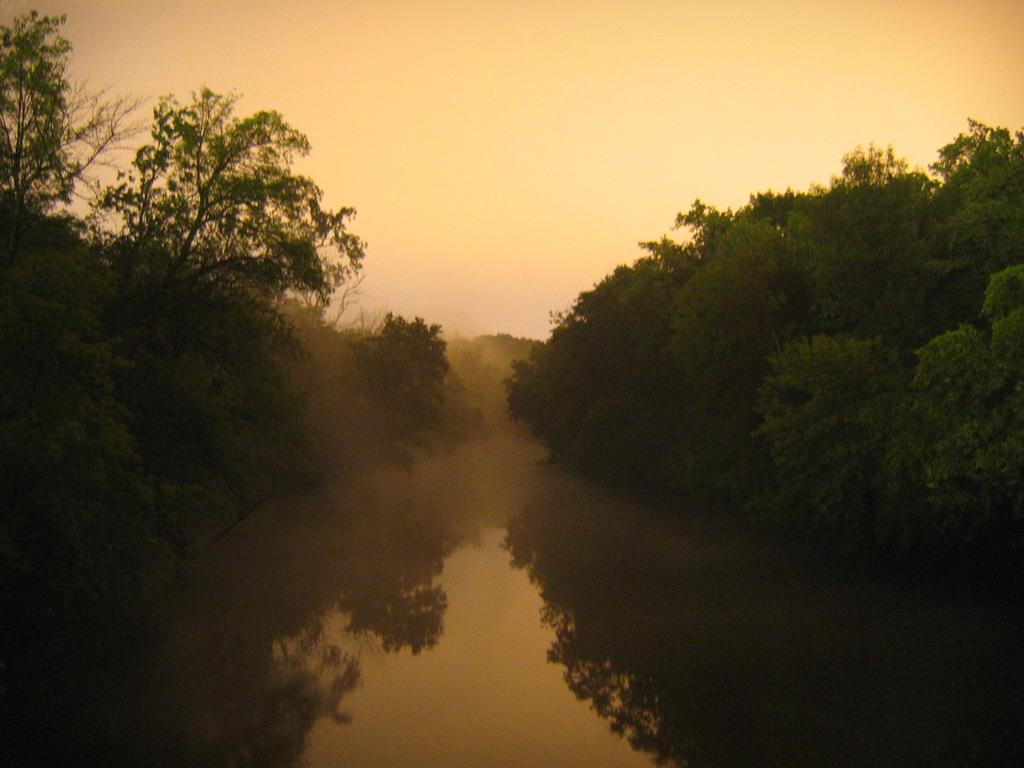What type of vegetation can be seen in the image? There are trees in the image. What natural element is visible in the image besides the trees? There is water visible in the image. What is the condition of the sky in the image? The sky is cloudy in the image. What type of wrench is being used to control the machine in the image? There is no wrench or machine present in the image; it features trees and water. 